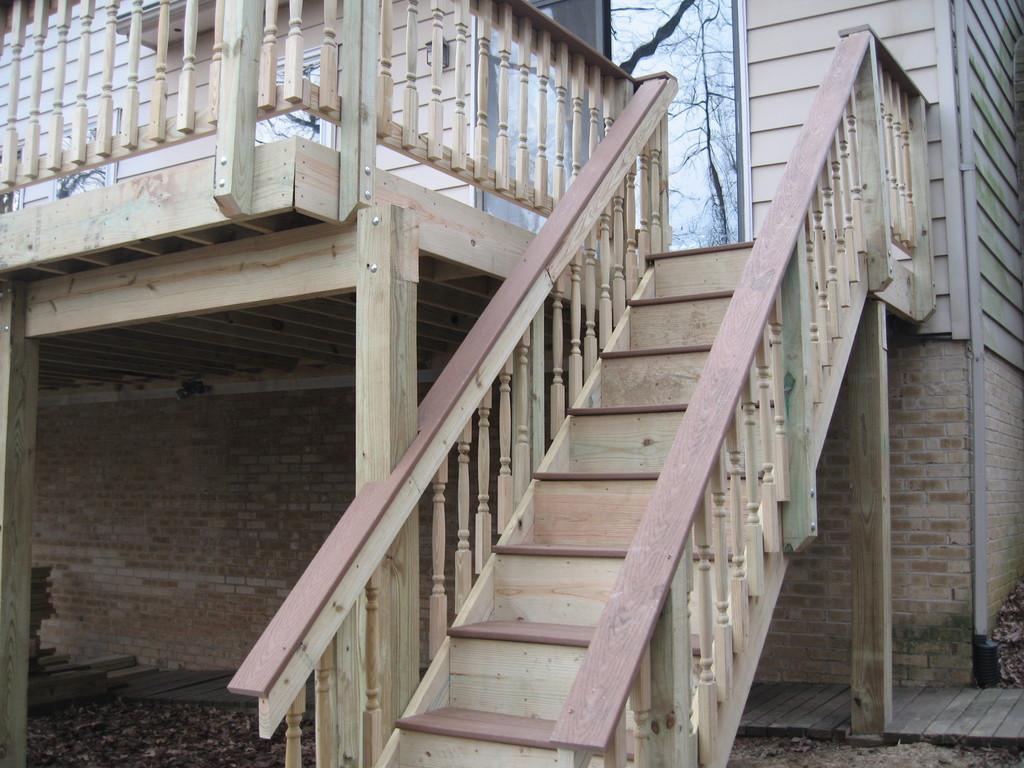Could you give a brief overview of what you see in this image? In the image there is a wooden home with a staircase in the middle, in the back there is glass door. 